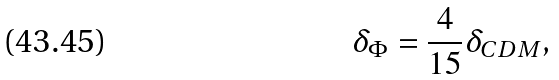<formula> <loc_0><loc_0><loc_500><loc_500>\delta _ { \Phi } = \frac { 4 } { 1 5 } \delta _ { C D M } ,</formula> 